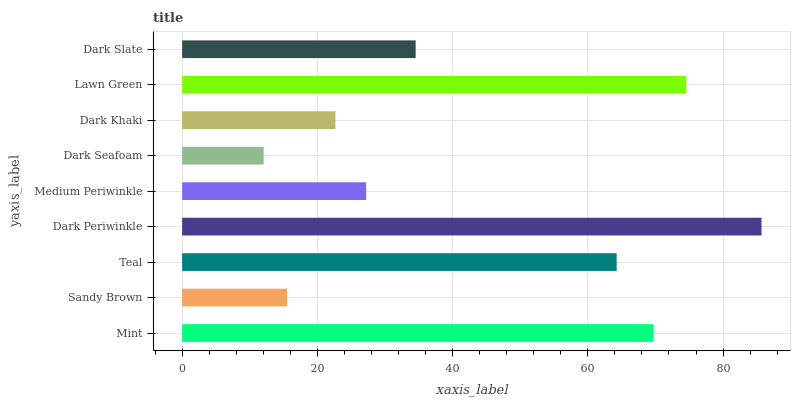Is Dark Seafoam the minimum?
Answer yes or no. Yes. Is Dark Periwinkle the maximum?
Answer yes or no. Yes. Is Sandy Brown the minimum?
Answer yes or no. No. Is Sandy Brown the maximum?
Answer yes or no. No. Is Mint greater than Sandy Brown?
Answer yes or no. Yes. Is Sandy Brown less than Mint?
Answer yes or no. Yes. Is Sandy Brown greater than Mint?
Answer yes or no. No. Is Mint less than Sandy Brown?
Answer yes or no. No. Is Dark Slate the high median?
Answer yes or no. Yes. Is Dark Slate the low median?
Answer yes or no. Yes. Is Dark Periwinkle the high median?
Answer yes or no. No. Is Dark Periwinkle the low median?
Answer yes or no. No. 